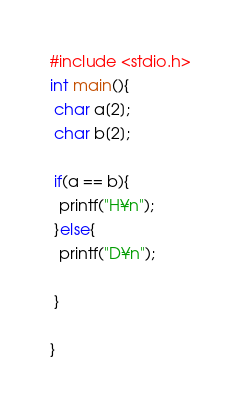<code> <loc_0><loc_0><loc_500><loc_500><_C_>#include <stdio.h>
int main(){
 char a[2];
 char b[2];
 
 if(a == b){
  printf("H¥n");
 }else{
  printf("D¥n");
 
 }

}
</code> 